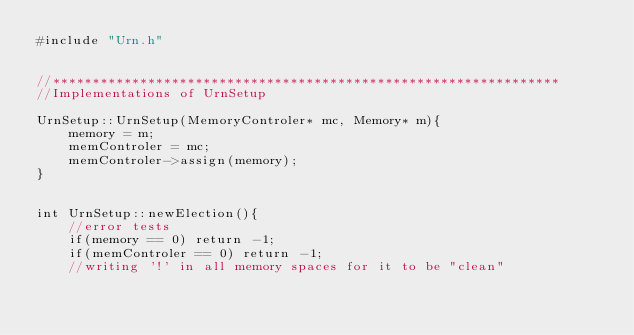<code> <loc_0><loc_0><loc_500><loc_500><_C++_>#include "Urn.h"


//****************************************************************
//Implementations of UrnSetup

UrnSetup::UrnSetup(MemoryControler* mc, Memory* m){
    memory = m;
    memControler = mc;
    memControler->assign(memory);
}


int UrnSetup::newElection(){
    //error tests
    if(memory == 0) return -1;
    if(memControler == 0) return -1;
    //writing '!' in all memory spaces for it to be "clean"</code> 